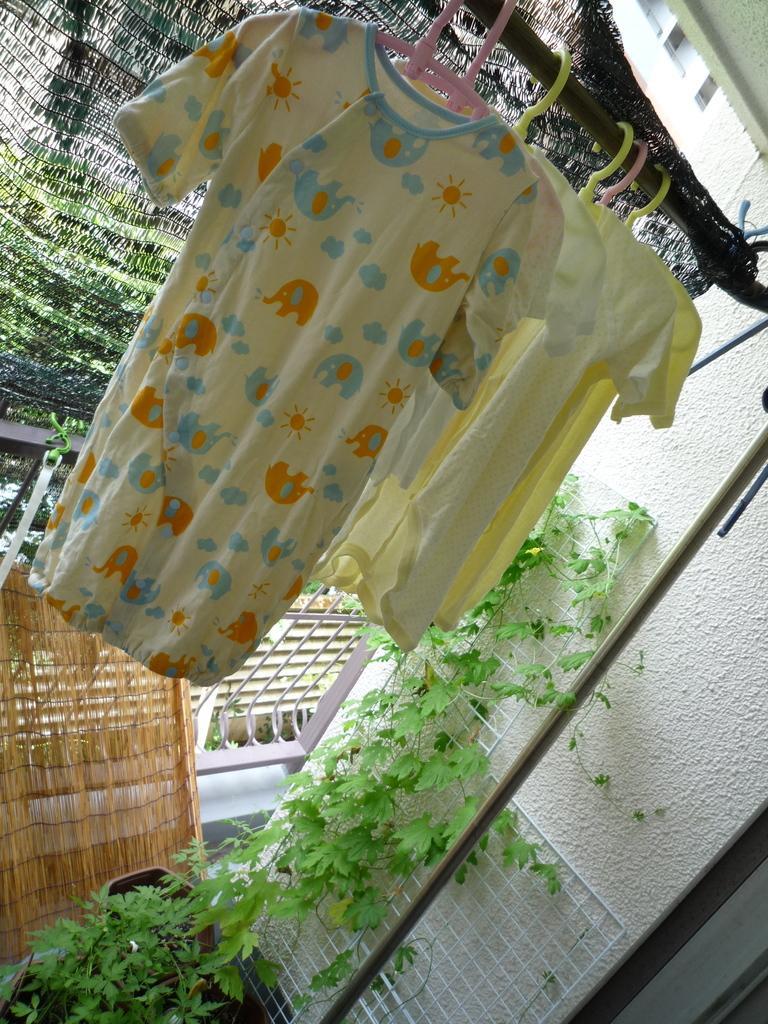Can you describe this image briefly? There are clothes hanging to a rod. Here we can see planets, grill, and wall. 